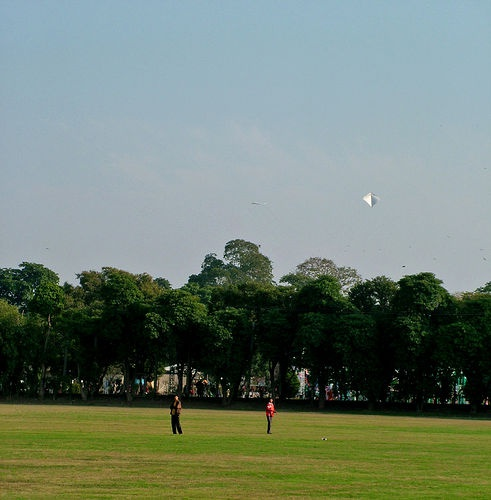Describe the objects in this image and their specific colors. I can see people in lightblue, black, olive, maroon, and gray tones, people in lightblue, black, maroon, and gray tones, and kite in lightblue, darkgray, lightgray, and gray tones in this image. 